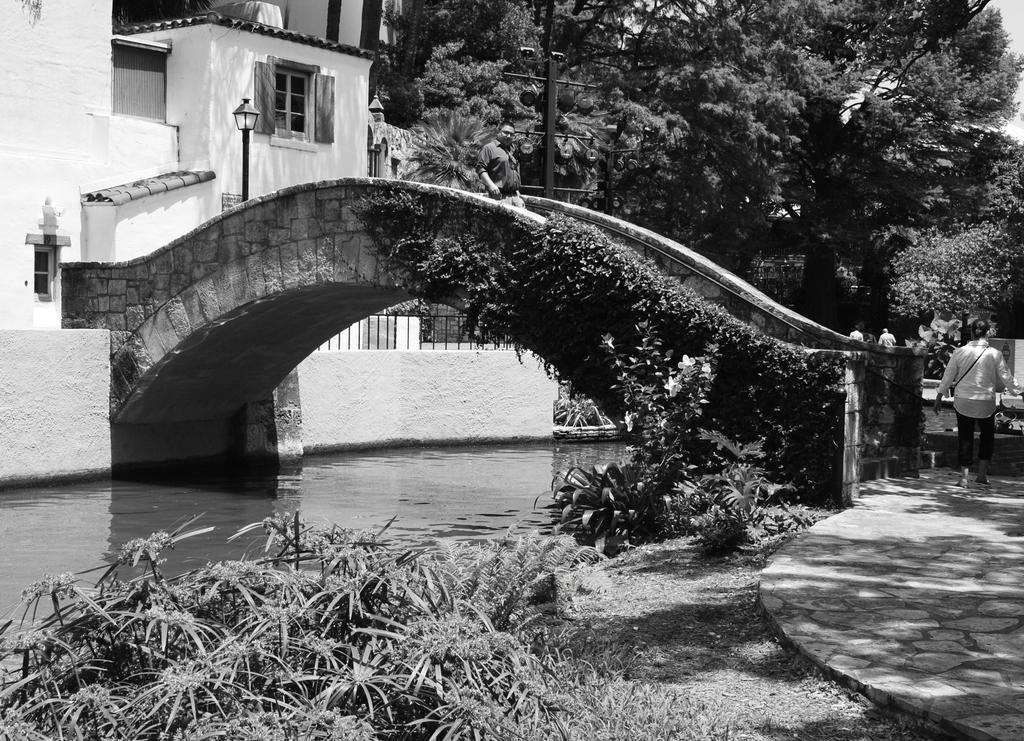Could you give a brief overview of what you see in this image? It looks like a black and white picture. We can see a person is walking on the path and on the left side of the person there is a bridge and under the bridge there is water and plants and behind the bridge there is a pole with a light, building and trees. 